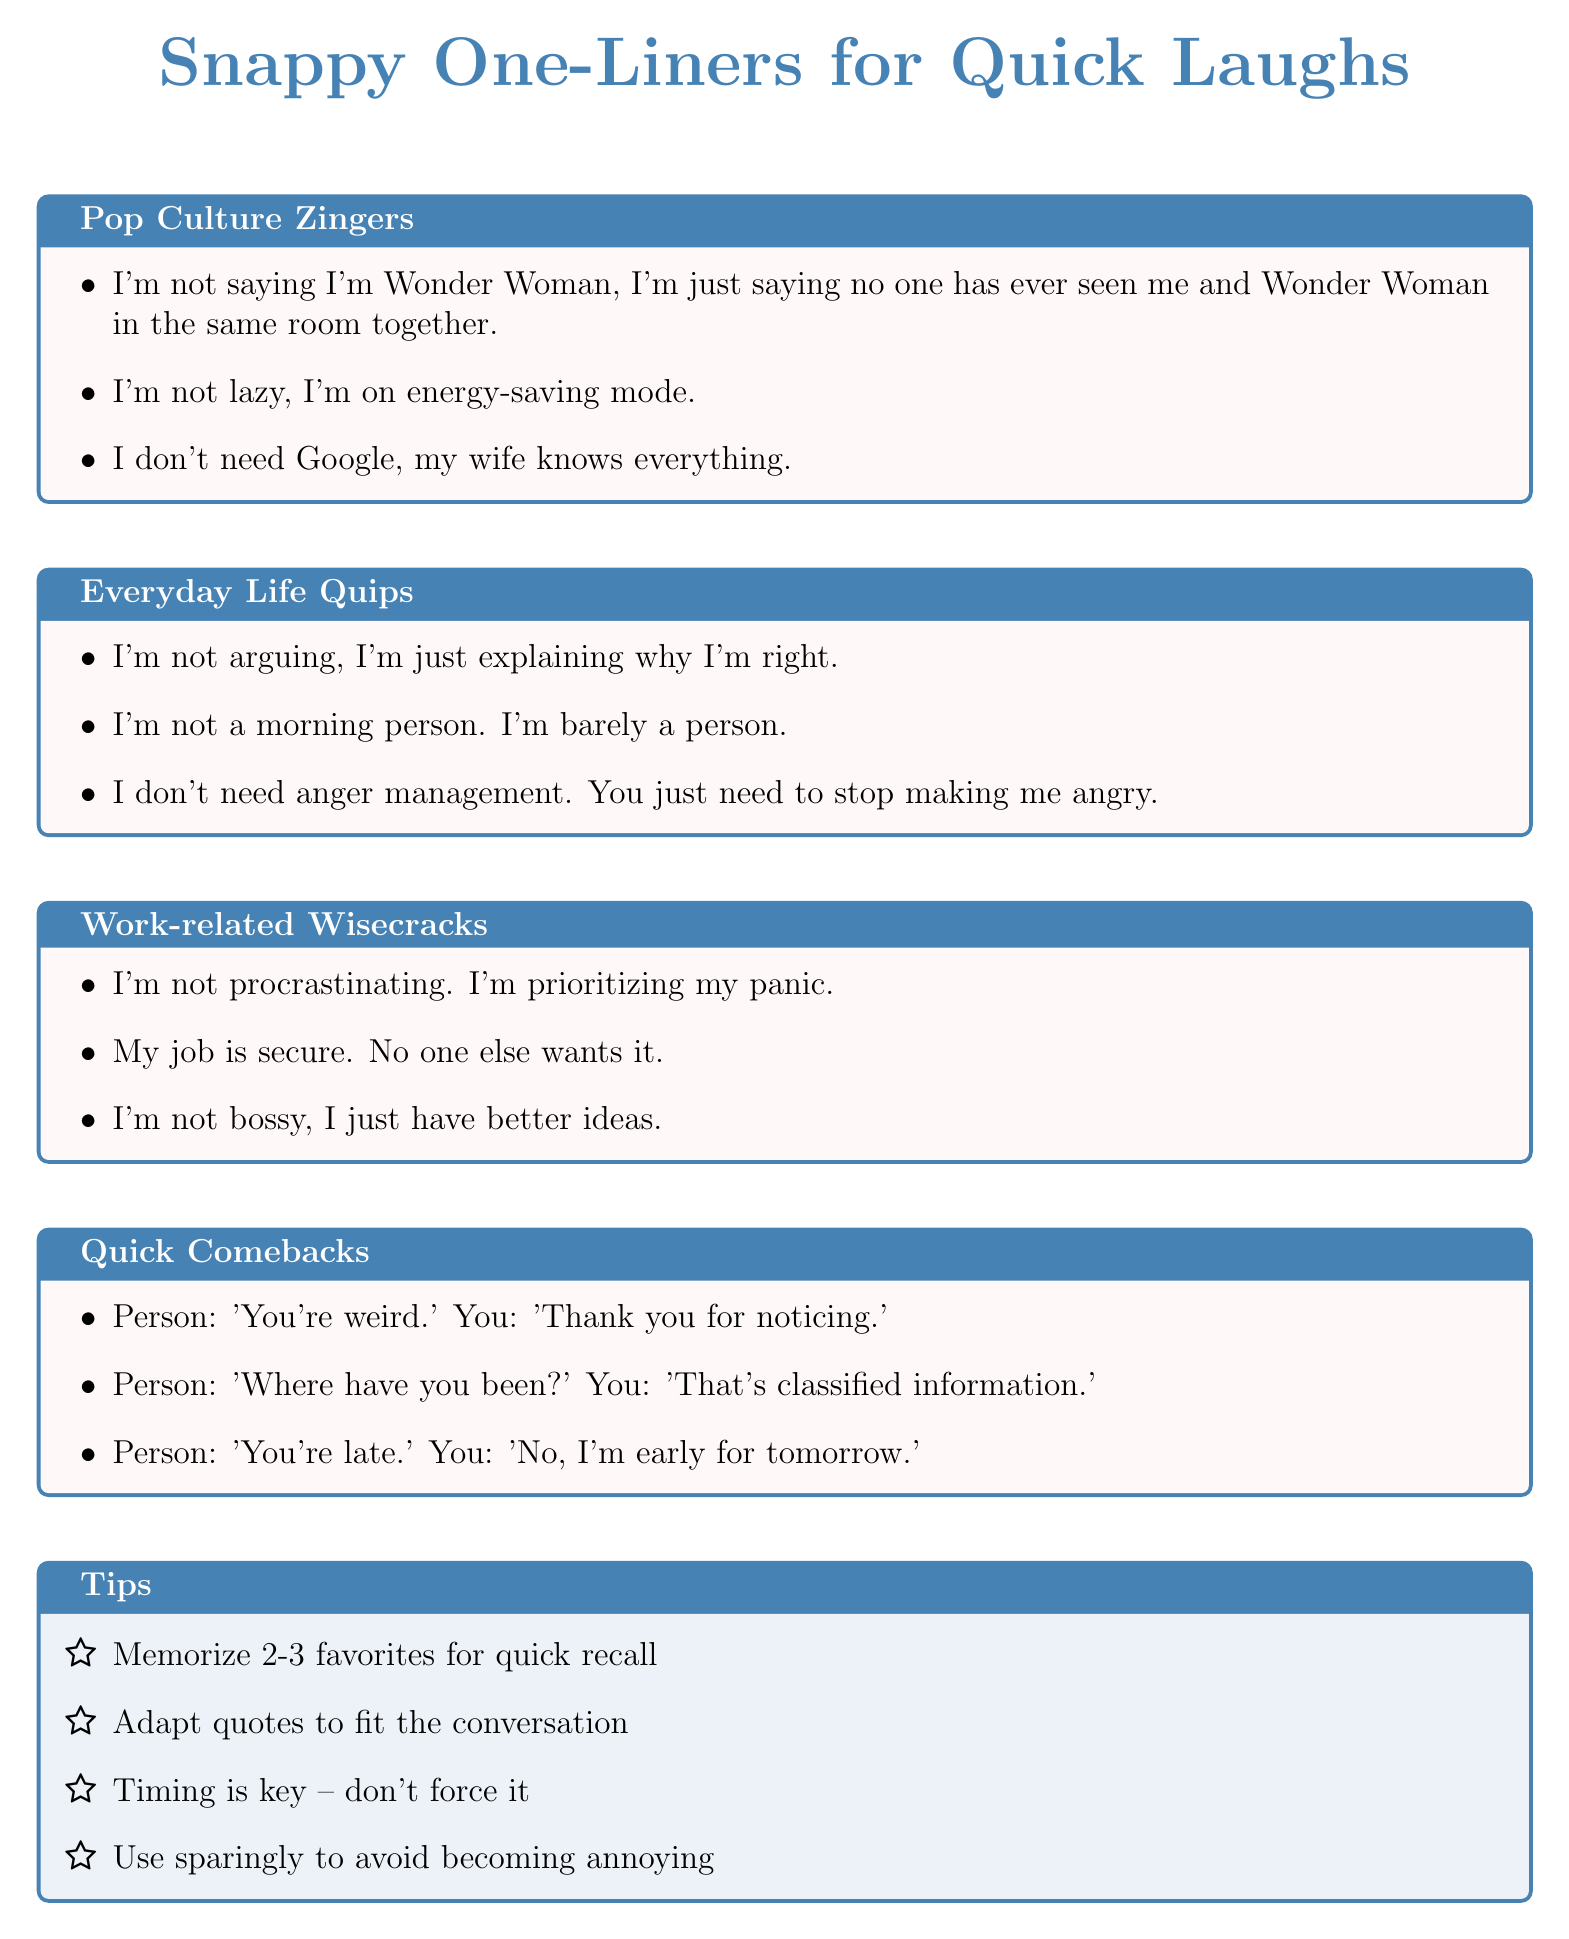What is the title of the document? The title is stated at the beginning of the document.
Answer: Snappy One-Liners for Quick Laughs How many sections are there in the document? The document has a list of multiple distinct sections.
Answer: 4 What is one of the quotes from the "Pop Culture Zingers" section? The question refers to specific content in that particular section.
Answer: I'm not lazy, I'm on energy-saving mode Which quote suggests a relationship with a spouse? This requires finding a quote that references a personal relationship.
Answer: I don't need Google, my wife knows everything What is a tip offered in the document? The document lists specific tips at the end.
Answer: Memorize 2-3 favorites for quick recall Which section includes work-related quotes? The reasoning involves identifying sections by their content type.
Answer: Work-related Wisecracks 